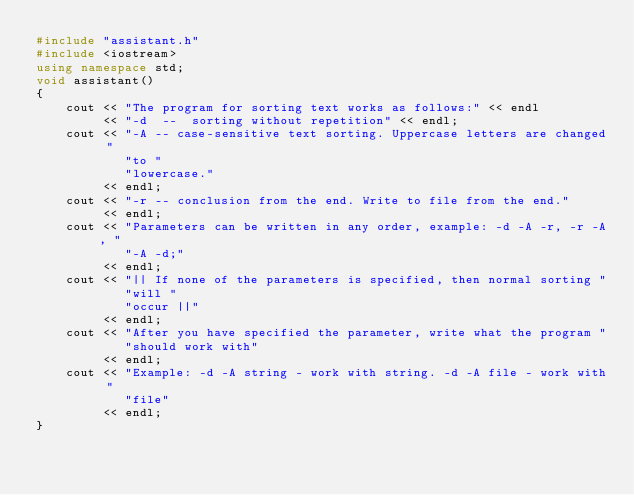Convert code to text. <code><loc_0><loc_0><loc_500><loc_500><_C++_>#include "assistant.h"
#include <iostream>
using namespace std;
void assistant()
{
    cout << "The program for sorting text works as follows:" << endl
         << "-d  --  sorting without repetition" << endl;
    cout << "-A -- case-sensitive text sorting. Uppercase letters are changed "
            "to "
            "lowercase."
         << endl;
    cout << "-r -- conclusion from the end. Write to file from the end."
         << endl;
    cout << "Parameters can be written in any order, example: -d -A -r, -r -A, "
            "-A -d;"
         << endl;
    cout << "|| If none of the parameters is specified, then normal sorting "
            "will "
            "occur ||"
         << endl;
    cout << "After you have specified the parameter, write what the program "
            "should work with"
         << endl;
    cout << "Example: -d -A string - work with string. -d -A file - work with "
            "file"
         << endl;
}
</code> 